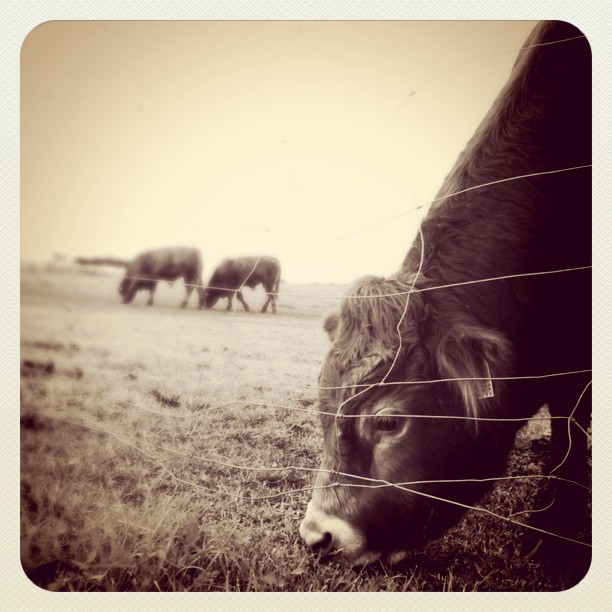Can you tell me about the setting where these animals are found? Certainly! This image captures a bucolic setting, likely a farm or rural pasture land. The cattle are in an open field with a wide horizon, suggesting a tranquil, spacious environment commonly found in agricultural areas. 